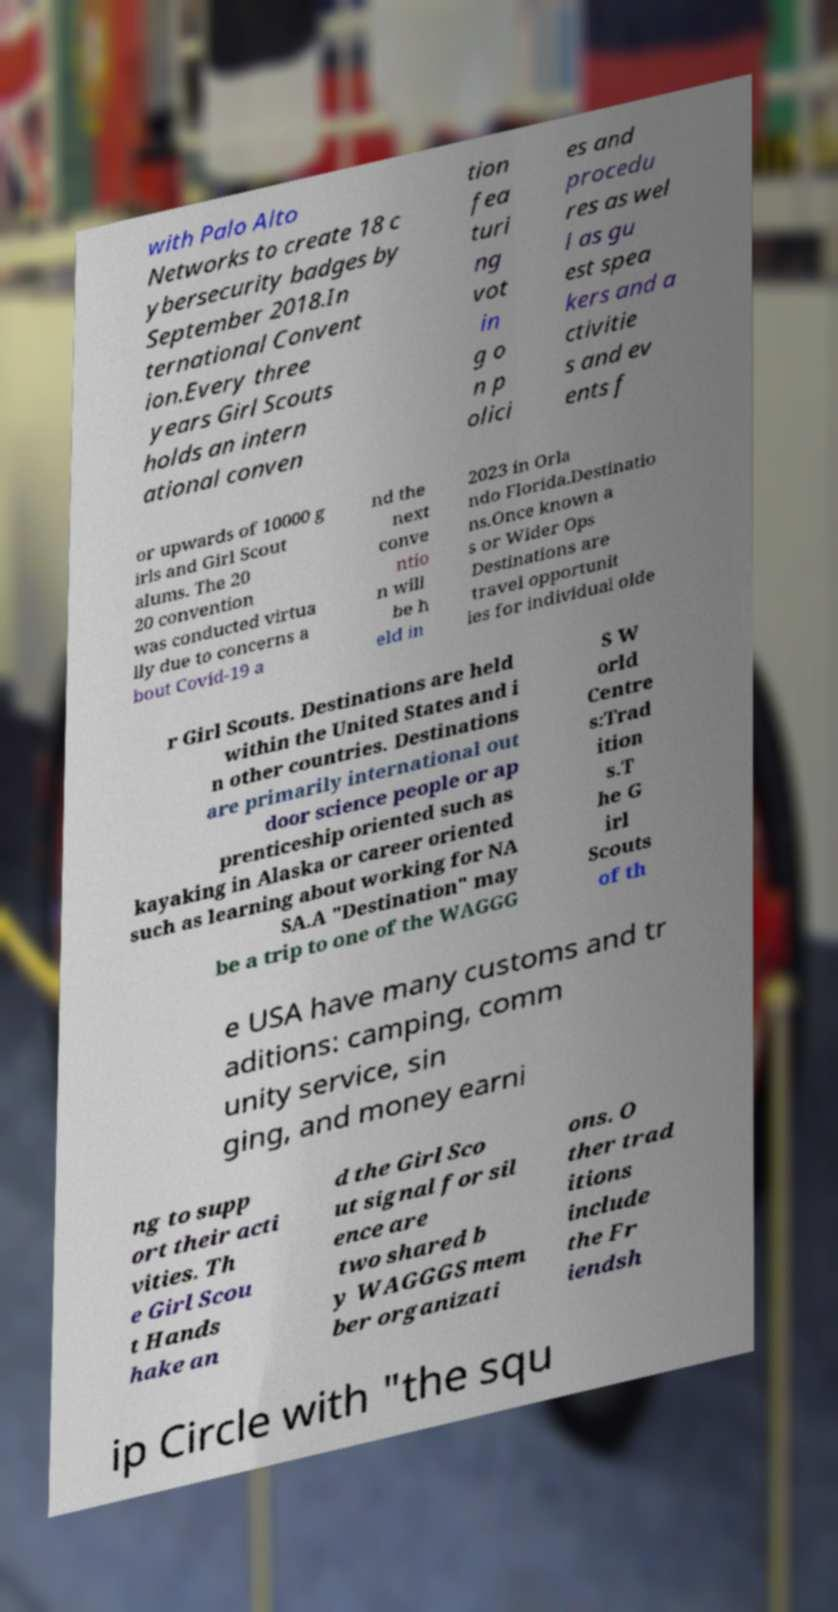Please identify and transcribe the text found in this image. with Palo Alto Networks to create 18 c ybersecurity badges by September 2018.In ternational Convent ion.Every three years Girl Scouts holds an intern ational conven tion fea turi ng vot in g o n p olici es and procedu res as wel l as gu est spea kers and a ctivitie s and ev ents f or upwards of 10000 g irls and Girl Scout alums. The 20 20 convention was conducted virtua lly due to concerns a bout Covid-19 a nd the next conve ntio n will be h eld in 2023 in Orla ndo Florida.Destinatio ns.Once known a s or Wider Ops Destinations are travel opportunit ies for individual olde r Girl Scouts. Destinations are held within the United States and i n other countries. Destinations are primarily international out door science people or ap prenticeship oriented such as kayaking in Alaska or career oriented such as learning about working for NA SA.A "Destination" may be a trip to one of the WAGGG S W orld Centre s:Trad ition s.T he G irl Scouts of th e USA have many customs and tr aditions: camping, comm unity service, sin ging, and money earni ng to supp ort their acti vities. Th e Girl Scou t Hands hake an d the Girl Sco ut signal for sil ence are two shared b y WAGGGS mem ber organizati ons. O ther trad itions include the Fr iendsh ip Circle with "the squ 